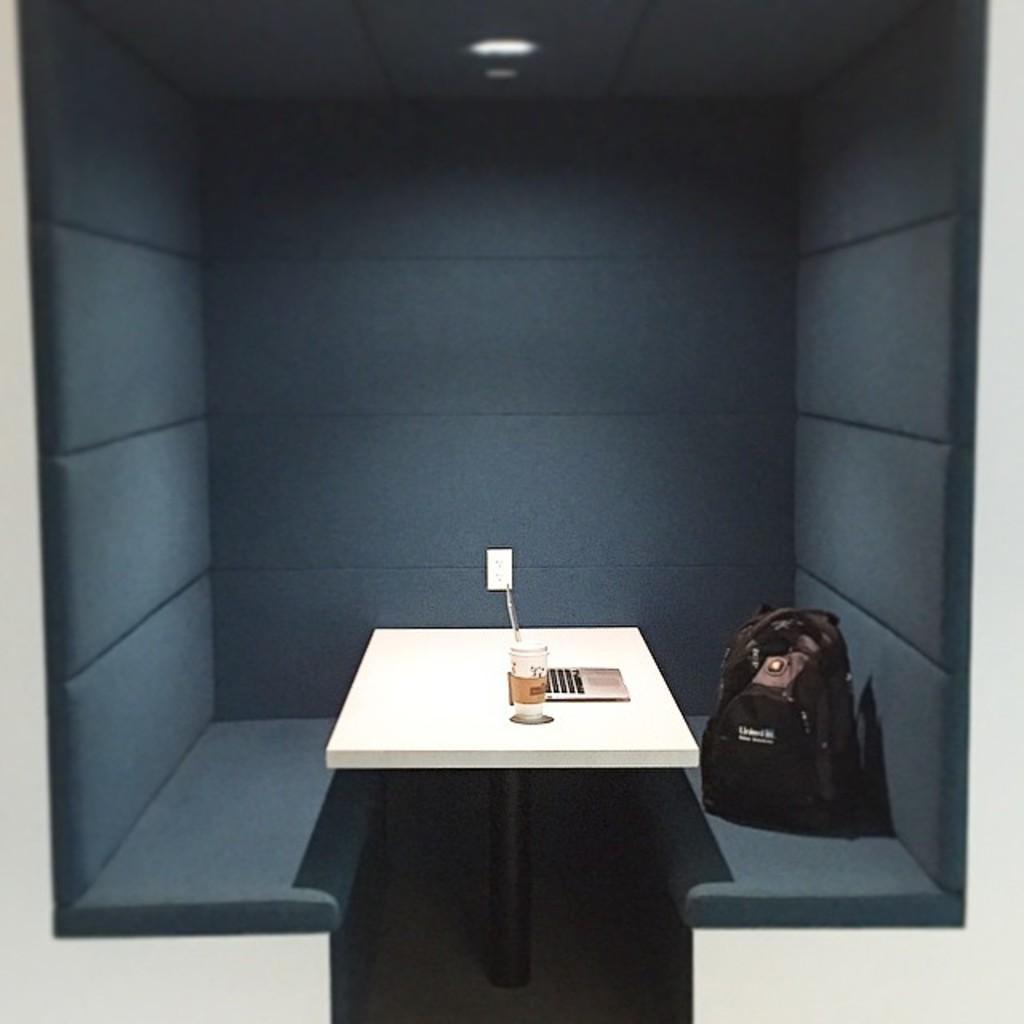How would you summarize this image in a sentence or two? In this image we can see a table with a laptop and a glass. To the right side of the image there is a bag on the seat. In the background of the image there is wall. At the top of the image there is ceiling with light. 